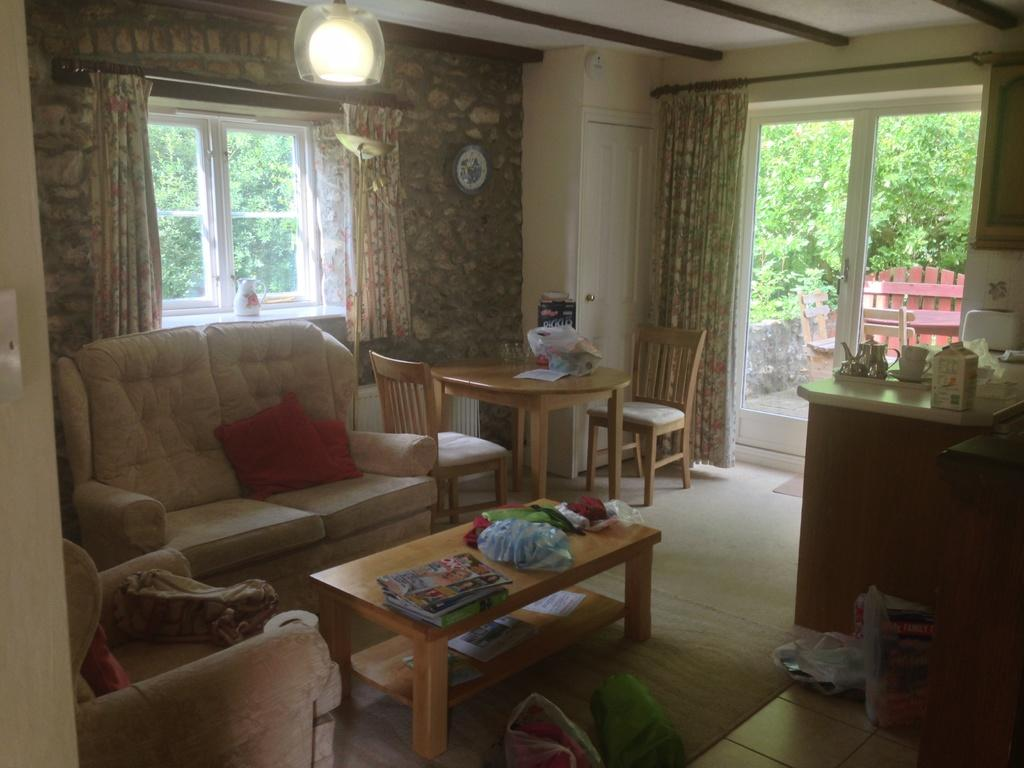What type of space is shown in the image? The image is of the inside of a room. What type of furniture is present in the room? There is a sofa, chairs, and tables in the room. What type of decorative items can be seen in the room? There are pillows in the room. What type of window is present in the room? There is a glass window in the room. What type of window treatment is present in the room? There are curtains in the room. What type of wall is present in the room? There is a wall in the room. What type of flooring is visible in the room? The floor is visible in the room. What is on the table in the room? There are things on the table. What can be seen through the glass window in the room? Trees are visible through the glass window. What type of songs can be heard coming from the dirt in the image? There is no dirt present in the image, and therefore no songs can be heard coming from it. 